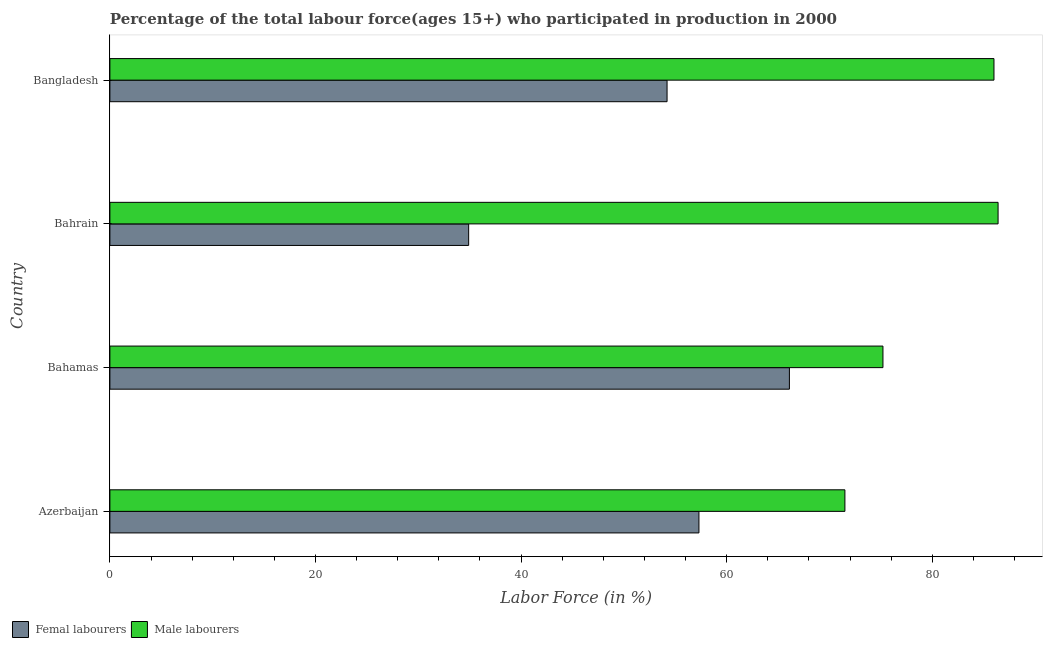How many groups of bars are there?
Your answer should be compact. 4. Are the number of bars per tick equal to the number of legend labels?
Provide a short and direct response. Yes. Are the number of bars on each tick of the Y-axis equal?
Your answer should be very brief. Yes. How many bars are there on the 2nd tick from the top?
Provide a short and direct response. 2. How many bars are there on the 1st tick from the bottom?
Your answer should be very brief. 2. What is the percentage of male labour force in Bahrain?
Your answer should be very brief. 86.4. Across all countries, what is the maximum percentage of male labour force?
Ensure brevity in your answer.  86.4. Across all countries, what is the minimum percentage of male labour force?
Your answer should be compact. 71.5. In which country was the percentage of female labor force maximum?
Your answer should be compact. Bahamas. In which country was the percentage of female labor force minimum?
Your answer should be compact. Bahrain. What is the total percentage of male labour force in the graph?
Your answer should be very brief. 319.1. What is the difference between the percentage of female labor force in Azerbaijan and that in Bangladesh?
Your answer should be very brief. 3.1. What is the difference between the percentage of male labour force in Bahrain and the percentage of female labor force in Azerbaijan?
Your response must be concise. 29.1. What is the average percentage of female labor force per country?
Give a very brief answer. 53.12. What is the difference between the percentage of male labour force and percentage of female labor force in Bahrain?
Give a very brief answer. 51.5. What is the ratio of the percentage of male labour force in Bahamas to that in Bangladesh?
Provide a succinct answer. 0.87. Is the difference between the percentage of male labour force in Bahamas and Bahrain greater than the difference between the percentage of female labor force in Bahamas and Bahrain?
Ensure brevity in your answer.  No. What is the difference between the highest and the second highest percentage of male labour force?
Ensure brevity in your answer.  0.4. What is the difference between the highest and the lowest percentage of female labor force?
Provide a short and direct response. 31.2. What does the 1st bar from the top in Bahrain represents?
Provide a short and direct response. Male labourers. What does the 1st bar from the bottom in Azerbaijan represents?
Keep it short and to the point. Femal labourers. How many bars are there?
Your response must be concise. 8. Are all the bars in the graph horizontal?
Keep it short and to the point. Yes. How many countries are there in the graph?
Make the answer very short. 4. Does the graph contain any zero values?
Your answer should be compact. No. How many legend labels are there?
Your response must be concise. 2. How are the legend labels stacked?
Provide a short and direct response. Horizontal. What is the title of the graph?
Provide a succinct answer. Percentage of the total labour force(ages 15+) who participated in production in 2000. What is the label or title of the Y-axis?
Your answer should be very brief. Country. What is the Labor Force (in %) of Femal labourers in Azerbaijan?
Give a very brief answer. 57.3. What is the Labor Force (in %) of Male labourers in Azerbaijan?
Ensure brevity in your answer.  71.5. What is the Labor Force (in %) in Femal labourers in Bahamas?
Ensure brevity in your answer.  66.1. What is the Labor Force (in %) in Male labourers in Bahamas?
Your answer should be very brief. 75.2. What is the Labor Force (in %) in Femal labourers in Bahrain?
Keep it short and to the point. 34.9. What is the Labor Force (in %) in Male labourers in Bahrain?
Give a very brief answer. 86.4. What is the Labor Force (in %) of Femal labourers in Bangladesh?
Keep it short and to the point. 54.2. Across all countries, what is the maximum Labor Force (in %) of Femal labourers?
Your answer should be compact. 66.1. Across all countries, what is the maximum Labor Force (in %) of Male labourers?
Provide a short and direct response. 86.4. Across all countries, what is the minimum Labor Force (in %) of Femal labourers?
Your answer should be compact. 34.9. Across all countries, what is the minimum Labor Force (in %) in Male labourers?
Give a very brief answer. 71.5. What is the total Labor Force (in %) in Femal labourers in the graph?
Offer a terse response. 212.5. What is the total Labor Force (in %) in Male labourers in the graph?
Offer a terse response. 319.1. What is the difference between the Labor Force (in %) in Femal labourers in Azerbaijan and that in Bahrain?
Your answer should be very brief. 22.4. What is the difference between the Labor Force (in %) in Male labourers in Azerbaijan and that in Bahrain?
Provide a short and direct response. -14.9. What is the difference between the Labor Force (in %) in Femal labourers in Bahamas and that in Bahrain?
Your response must be concise. 31.2. What is the difference between the Labor Force (in %) in Femal labourers in Bahamas and that in Bangladesh?
Keep it short and to the point. 11.9. What is the difference between the Labor Force (in %) of Femal labourers in Bahrain and that in Bangladesh?
Make the answer very short. -19.3. What is the difference between the Labor Force (in %) in Femal labourers in Azerbaijan and the Labor Force (in %) in Male labourers in Bahamas?
Provide a short and direct response. -17.9. What is the difference between the Labor Force (in %) in Femal labourers in Azerbaijan and the Labor Force (in %) in Male labourers in Bahrain?
Keep it short and to the point. -29.1. What is the difference between the Labor Force (in %) of Femal labourers in Azerbaijan and the Labor Force (in %) of Male labourers in Bangladesh?
Your answer should be very brief. -28.7. What is the difference between the Labor Force (in %) in Femal labourers in Bahamas and the Labor Force (in %) in Male labourers in Bahrain?
Provide a succinct answer. -20.3. What is the difference between the Labor Force (in %) in Femal labourers in Bahamas and the Labor Force (in %) in Male labourers in Bangladesh?
Offer a terse response. -19.9. What is the difference between the Labor Force (in %) of Femal labourers in Bahrain and the Labor Force (in %) of Male labourers in Bangladesh?
Make the answer very short. -51.1. What is the average Labor Force (in %) of Femal labourers per country?
Ensure brevity in your answer.  53.12. What is the average Labor Force (in %) in Male labourers per country?
Offer a terse response. 79.78. What is the difference between the Labor Force (in %) in Femal labourers and Labor Force (in %) in Male labourers in Azerbaijan?
Offer a very short reply. -14.2. What is the difference between the Labor Force (in %) in Femal labourers and Labor Force (in %) in Male labourers in Bahrain?
Keep it short and to the point. -51.5. What is the difference between the Labor Force (in %) of Femal labourers and Labor Force (in %) of Male labourers in Bangladesh?
Ensure brevity in your answer.  -31.8. What is the ratio of the Labor Force (in %) in Femal labourers in Azerbaijan to that in Bahamas?
Offer a terse response. 0.87. What is the ratio of the Labor Force (in %) of Male labourers in Azerbaijan to that in Bahamas?
Your answer should be compact. 0.95. What is the ratio of the Labor Force (in %) of Femal labourers in Azerbaijan to that in Bahrain?
Offer a terse response. 1.64. What is the ratio of the Labor Force (in %) in Male labourers in Azerbaijan to that in Bahrain?
Offer a very short reply. 0.83. What is the ratio of the Labor Force (in %) in Femal labourers in Azerbaijan to that in Bangladesh?
Offer a terse response. 1.06. What is the ratio of the Labor Force (in %) of Male labourers in Azerbaijan to that in Bangladesh?
Offer a very short reply. 0.83. What is the ratio of the Labor Force (in %) of Femal labourers in Bahamas to that in Bahrain?
Keep it short and to the point. 1.89. What is the ratio of the Labor Force (in %) in Male labourers in Bahamas to that in Bahrain?
Offer a terse response. 0.87. What is the ratio of the Labor Force (in %) in Femal labourers in Bahamas to that in Bangladesh?
Your response must be concise. 1.22. What is the ratio of the Labor Force (in %) in Male labourers in Bahamas to that in Bangladesh?
Your answer should be compact. 0.87. What is the ratio of the Labor Force (in %) of Femal labourers in Bahrain to that in Bangladesh?
Give a very brief answer. 0.64. What is the ratio of the Labor Force (in %) in Male labourers in Bahrain to that in Bangladesh?
Make the answer very short. 1. What is the difference between the highest and the second highest Labor Force (in %) of Femal labourers?
Offer a terse response. 8.8. What is the difference between the highest and the second highest Labor Force (in %) in Male labourers?
Keep it short and to the point. 0.4. What is the difference between the highest and the lowest Labor Force (in %) of Femal labourers?
Give a very brief answer. 31.2. 